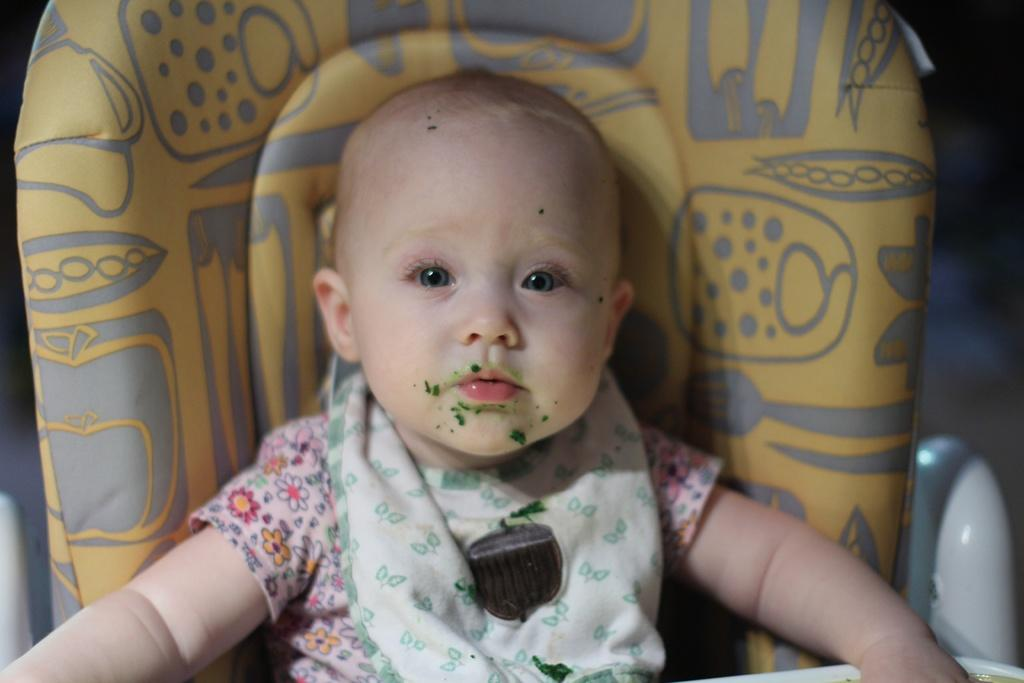What is the main subject of the image? The main subject of the image is a kid. What is the kid doing in the image? The kid is sitting on a chair in the image. Can you describe the background of the image? The background of the image is blurry. What type of pleasure can be seen on the face of the girl in the image? There is no girl present in the image, only a kid. What point is the kid trying to make in the image? The image does not provide any information about the kid's intentions or points, as it only shows the kid sitting on a chair. 